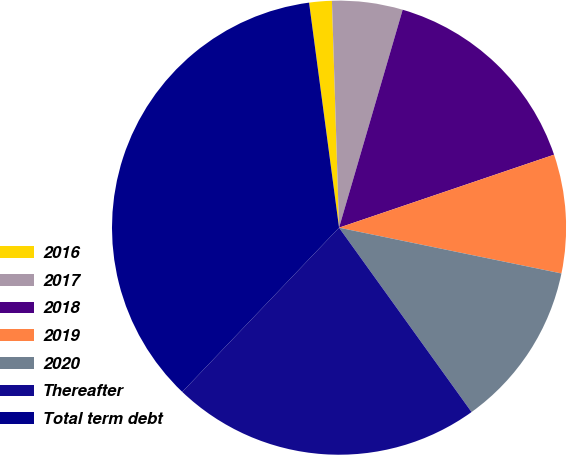<chart> <loc_0><loc_0><loc_500><loc_500><pie_chart><fcel>2016<fcel>2017<fcel>2018<fcel>2019<fcel>2020<fcel>Thereafter<fcel>Total term debt<nl><fcel>1.61%<fcel>5.02%<fcel>15.27%<fcel>8.44%<fcel>11.85%<fcel>22.05%<fcel>35.76%<nl></chart> 